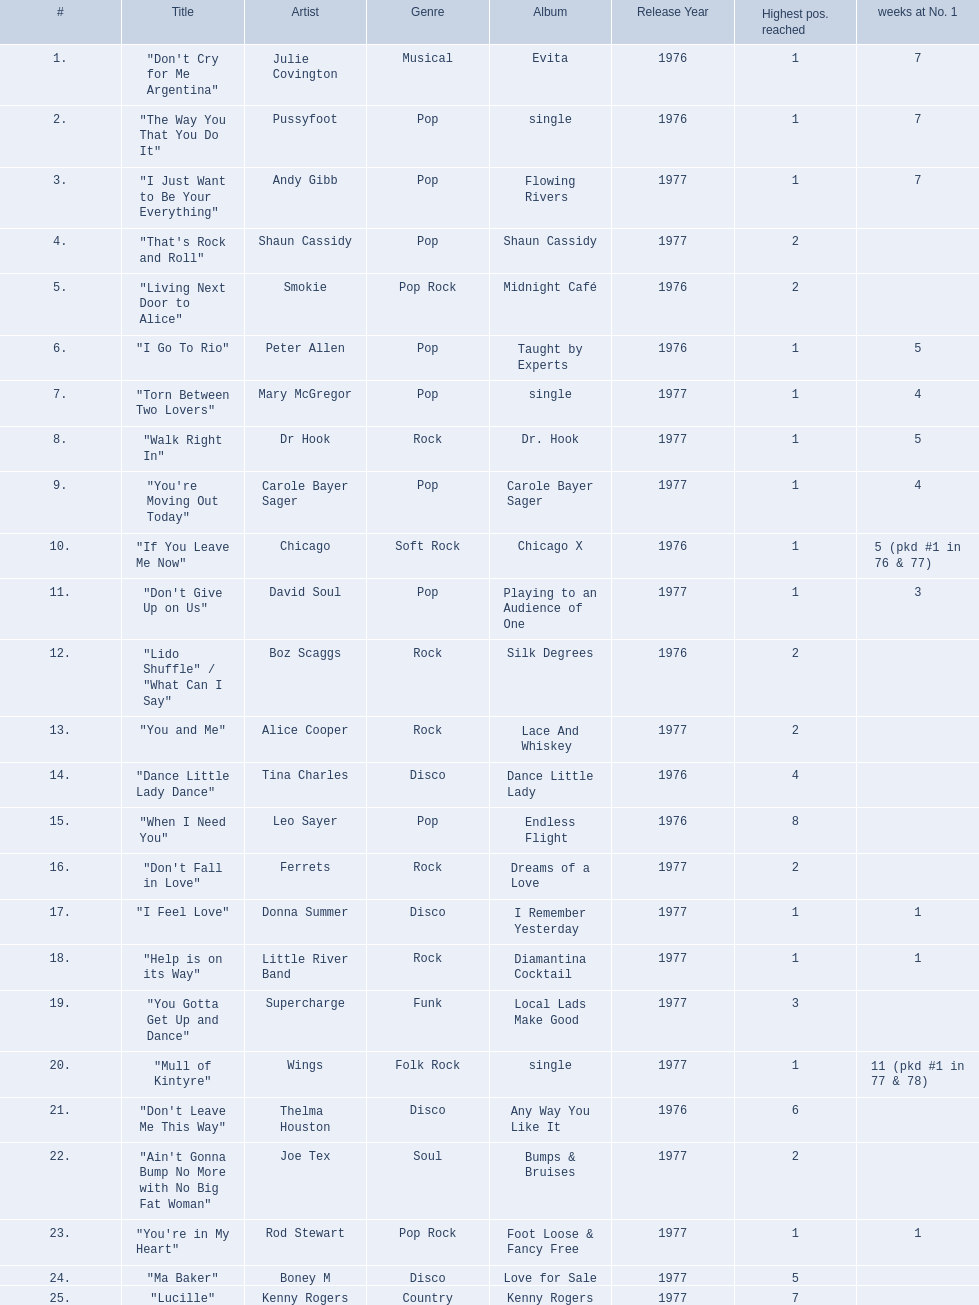Who had the one of the least weeks at number one? Rod Stewart. Who had no week at number one? Shaun Cassidy. Who had the highest number of weeks at number one? Wings. 